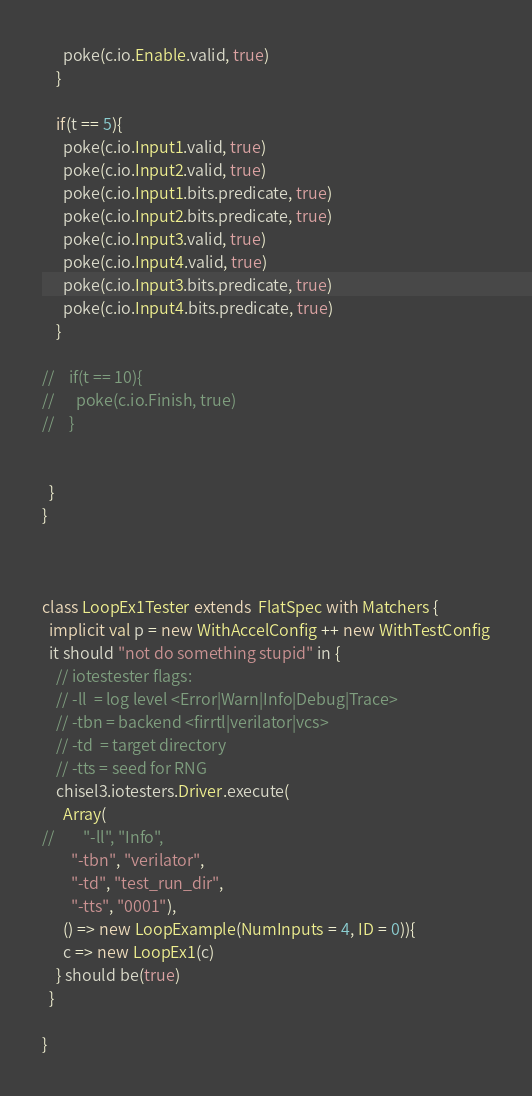Convert code to text. <code><loc_0><loc_0><loc_500><loc_500><_Scala_>      poke(c.io.Enable.valid, true)
    }

    if(t == 5){
      poke(c.io.Input1.valid, true)
      poke(c.io.Input2.valid, true)
      poke(c.io.Input1.bits.predicate, true)
      poke(c.io.Input2.bits.predicate, true)
      poke(c.io.Input3.valid, true)
      poke(c.io.Input4.valid, true)
      poke(c.io.Input3.bits.predicate, true)
      poke(c.io.Input4.bits.predicate, true)
    }

//    if(t == 10){
//      poke(c.io.Finish, true)
//    }


  }
}



class LoopEx1Tester extends  FlatSpec with Matchers {
  implicit val p = new WithAccelConfig ++ new WithTestConfig
  it should "not do something stupid" in {
    // iotestester flags:
    // -ll  = log level <Error|Warn|Info|Debug|Trace>
    // -tbn = backend <firrtl|verilator|vcs>
    // -td  = target directory
    // -tts = seed for RNG
    chisel3.iotesters.Driver.execute(
      Array(
//        "-ll", "Info",
        "-tbn", "verilator",
        "-td", "test_run_dir",
        "-tts", "0001"),
      () => new LoopExample(NumInputs = 4, ID = 0)){
      c => new LoopEx1(c)
    } should be(true)
  }

}

</code> 